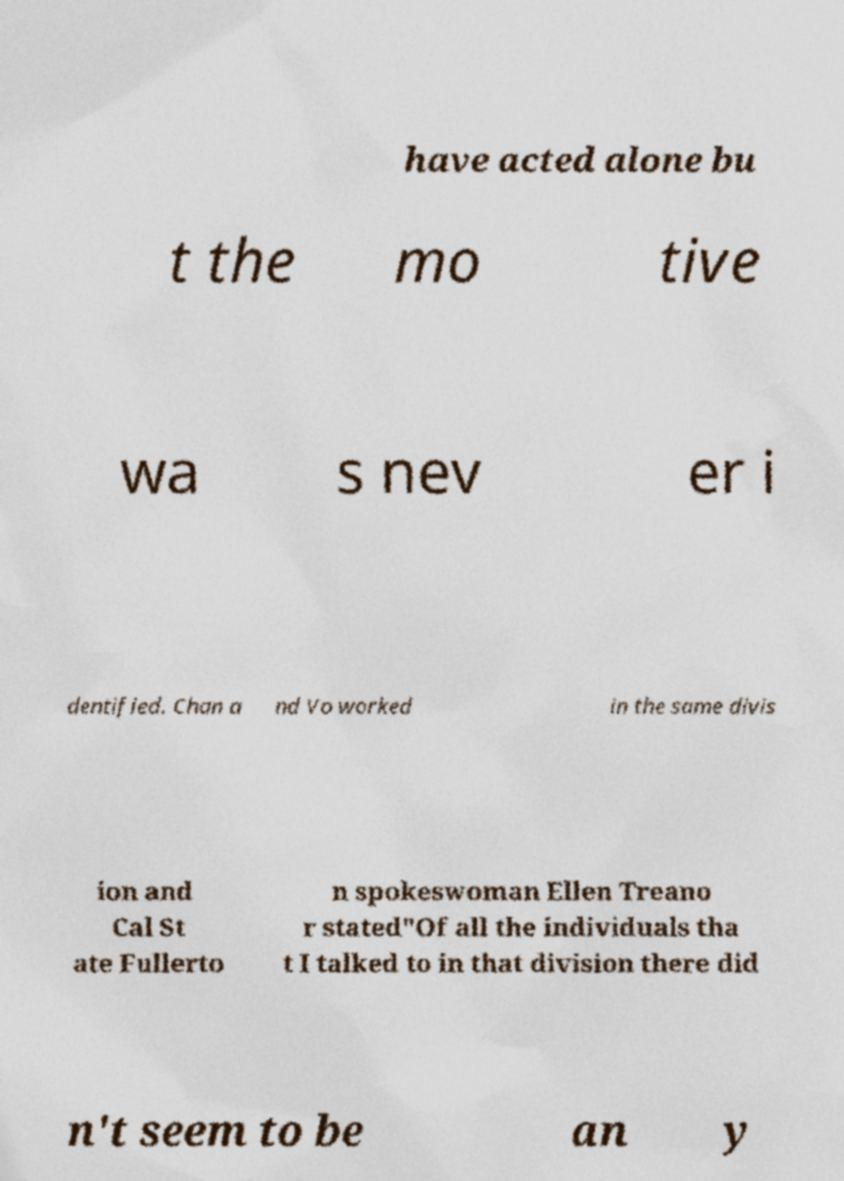I need the written content from this picture converted into text. Can you do that? have acted alone bu t the mo tive wa s nev er i dentified. Chan a nd Vo worked in the same divis ion and Cal St ate Fullerto n spokeswoman Ellen Treano r stated"Of all the individuals tha t I talked to in that division there did n't seem to be an y 